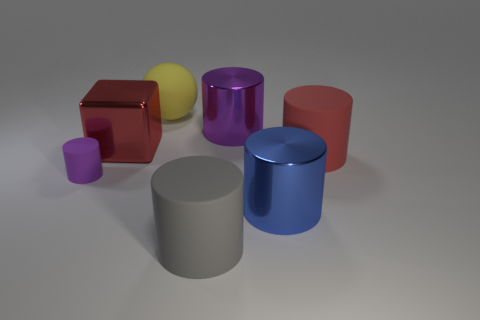Are there any other things that are the same size as the purple matte thing?
Offer a terse response. No. The other cylinder that is made of the same material as the blue cylinder is what color?
Your response must be concise. Purple. Is the red object right of the purple metal cylinder made of the same material as the purple thing on the left side of the gray matte thing?
Your response must be concise. Yes. What size is the metallic cylinder that is the same color as the tiny rubber cylinder?
Provide a succinct answer. Large. There is a big cylinder that is in front of the big blue object; what is its material?
Provide a succinct answer. Rubber. There is a purple thing that is left of the gray matte thing; is its shape the same as the red object that is to the left of the purple shiny cylinder?
Provide a succinct answer. No. There is a large cylinder that is the same color as the metallic block; what is its material?
Ensure brevity in your answer.  Rubber. Are any matte cylinders visible?
Give a very brief answer. Yes. What is the material of the large red object that is the same shape as the large blue thing?
Provide a short and direct response. Rubber. Are there any large purple cylinders in front of the big purple cylinder?
Your response must be concise. No. 